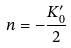<formula> <loc_0><loc_0><loc_500><loc_500>n = - { \frac { K _ { 0 } ^ { \prime } } { 2 } }</formula> 